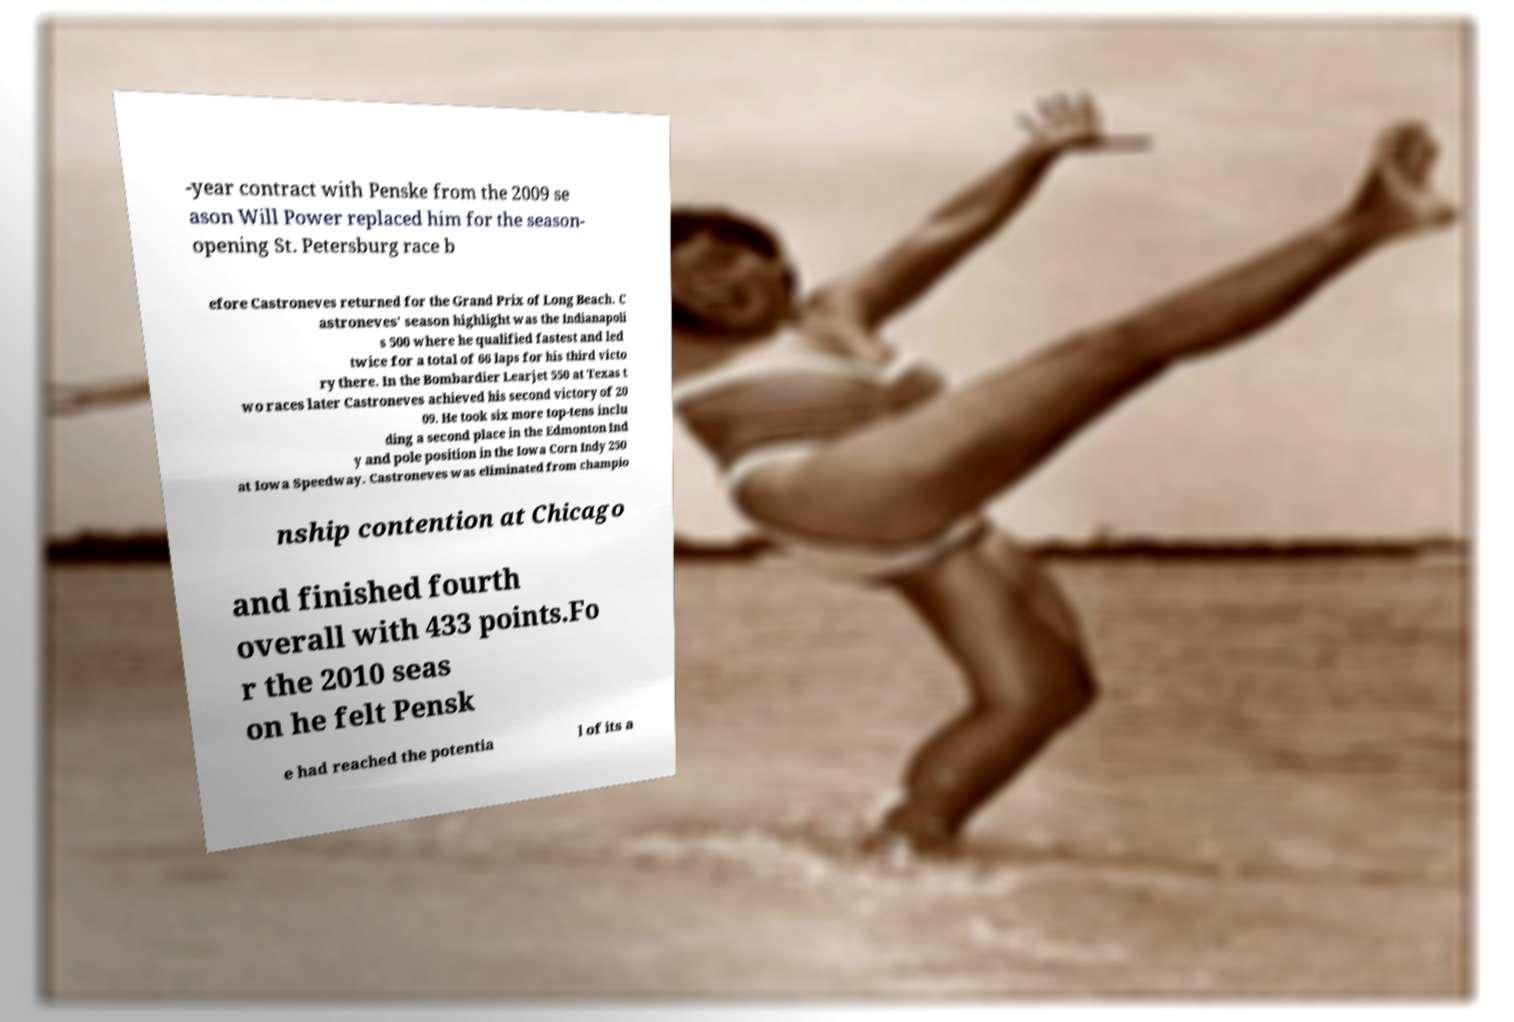Can you accurately transcribe the text from the provided image for me? -year contract with Penske from the 2009 se ason Will Power replaced him for the season- opening St. Petersburg race b efore Castroneves returned for the Grand Prix of Long Beach. C astroneves' season highlight was the Indianapoli s 500 where he qualified fastest and led twice for a total of 66 laps for his third victo ry there. In the Bombardier Learjet 550 at Texas t wo races later Castroneves achieved his second victory of 20 09. He took six more top-tens inclu ding a second place in the Edmonton Ind y and pole position in the Iowa Corn Indy 250 at Iowa Speedway. Castroneves was eliminated from champio nship contention at Chicago and finished fourth overall with 433 points.Fo r the 2010 seas on he felt Pensk e had reached the potentia l of its a 